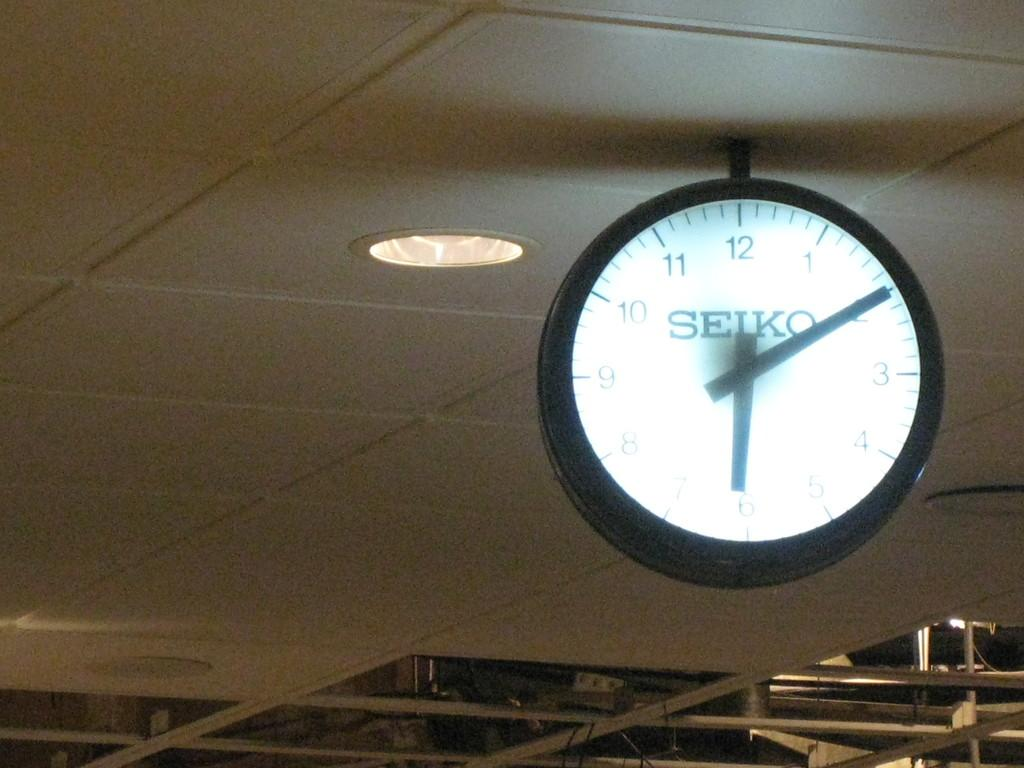<image>
Offer a succinct explanation of the picture presented. A Seiko clock is hanging from the ceiling. 